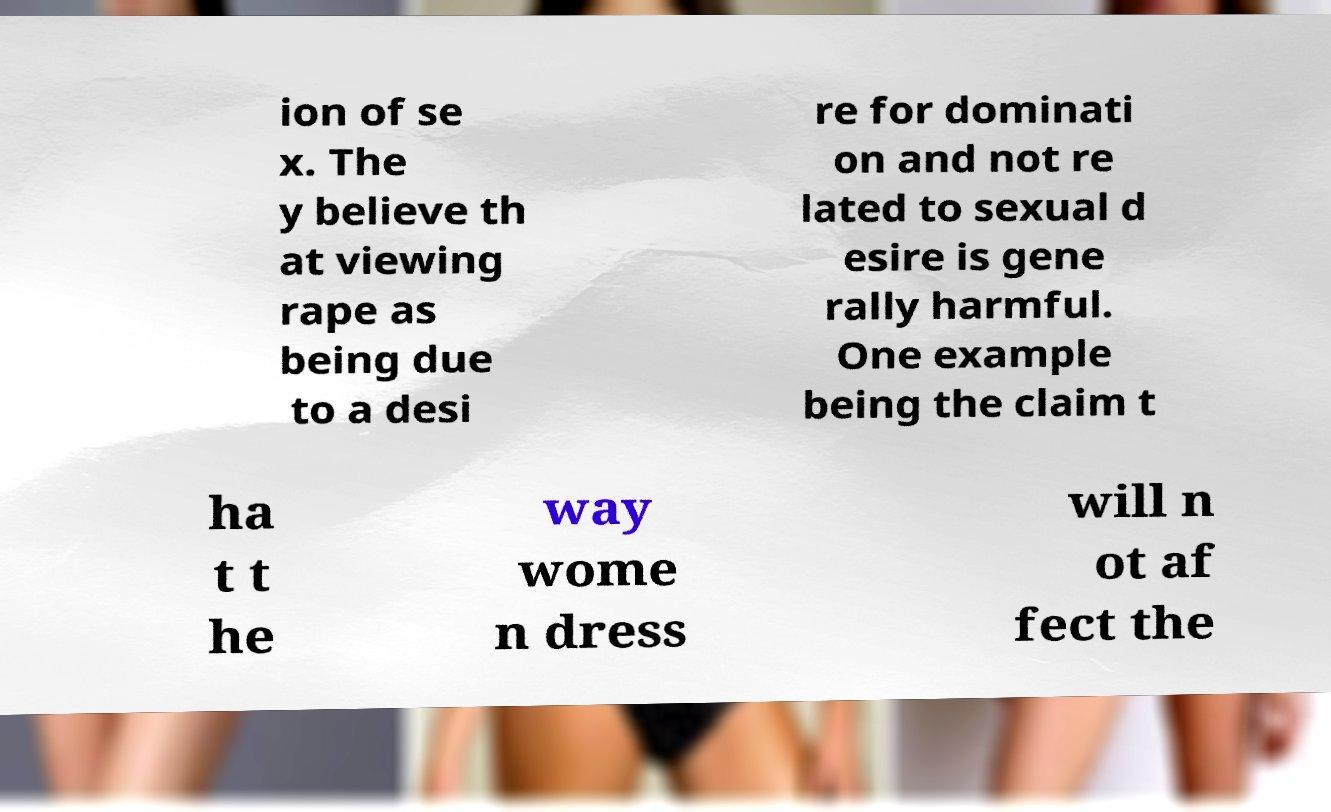Could you assist in decoding the text presented in this image and type it out clearly? ion of se x. The y believe th at viewing rape as being due to a desi re for dominati on and not re lated to sexual d esire is gene rally harmful. One example being the claim t ha t t he way wome n dress will n ot af fect the 